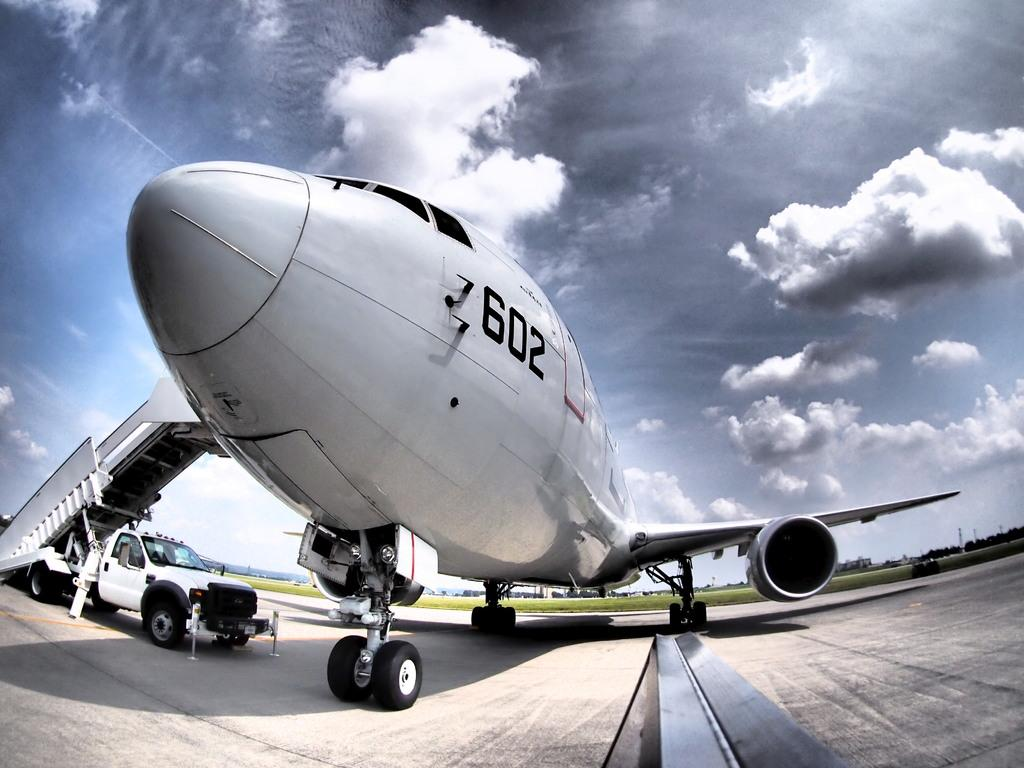<image>
Write a terse but informative summary of the picture. a plane with the numbers 602 on the side 